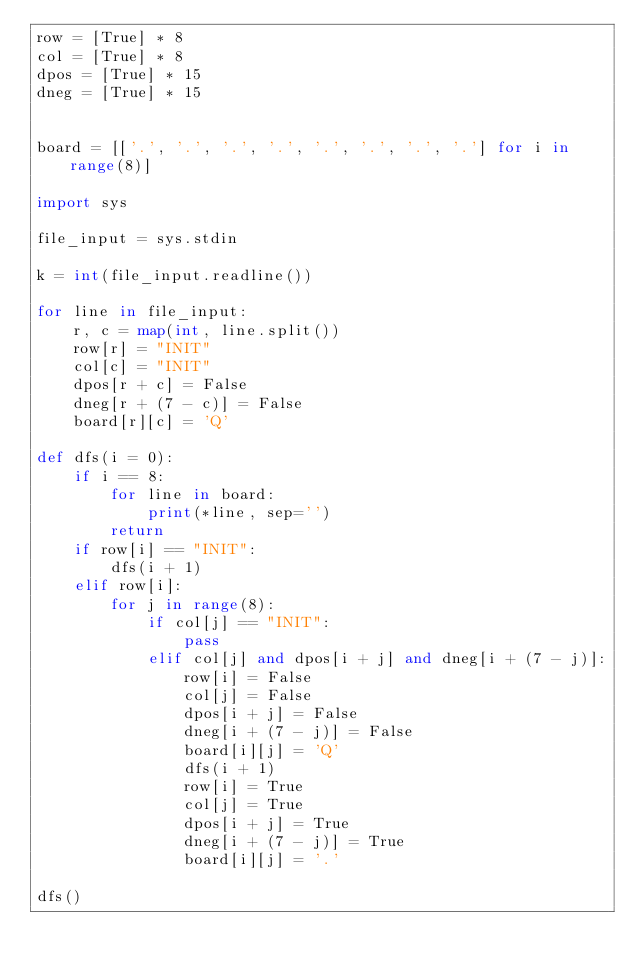Convert code to text. <code><loc_0><loc_0><loc_500><loc_500><_Python_>row = [True] * 8
col = [True] * 8
dpos = [True] * 15
dneg = [True] * 15


board = [['.', '.', '.', '.', '.', '.', '.', '.'] for i in range(8)]

import sys

file_input = sys.stdin

k = int(file_input.readline())

for line in file_input:
    r, c = map(int, line.split())
    row[r] = "INIT"
    col[c] = "INIT"
    dpos[r + c] = False
    dneg[r + (7 - c)] = False
    board[r][c] = 'Q'

def dfs(i = 0):
    if i == 8:
        for line in board:
            print(*line, sep='')
        return
    if row[i] == "INIT":
        dfs(i + 1)
    elif row[i]:
        for j in range(8):
            if col[j] == "INIT":
                pass
            elif col[j] and dpos[i + j] and dneg[i + (7 - j)]:
                row[i] = False
                col[j] = False
                dpos[i + j] = False
                dneg[i + (7 - j)] = False
                board[i][j] = 'Q'
                dfs(i + 1)
                row[i] = True
                col[j] = True
                dpos[i + j] = True
                dneg[i + (7 - j)] = True
                board[i][j] = '.'

dfs()</code> 